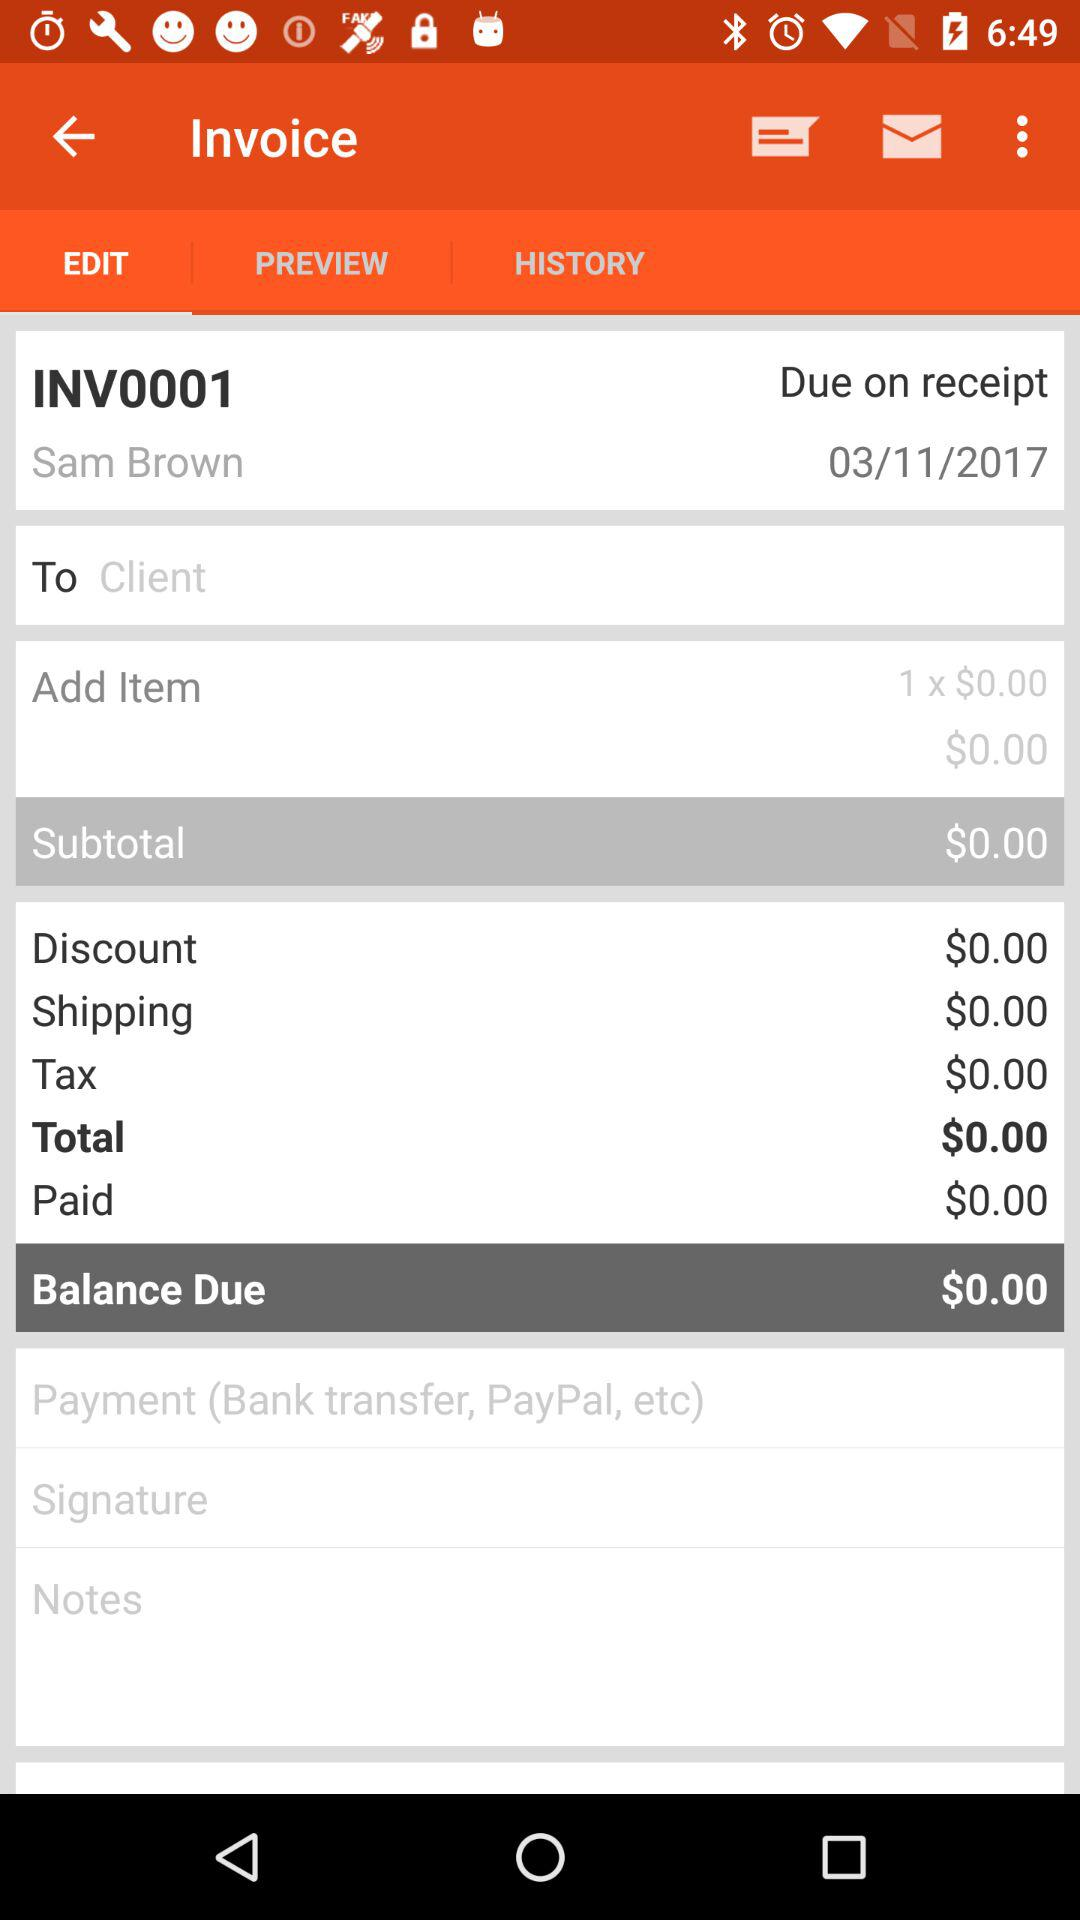What tab is selected? The selected tab is "EDIT". 